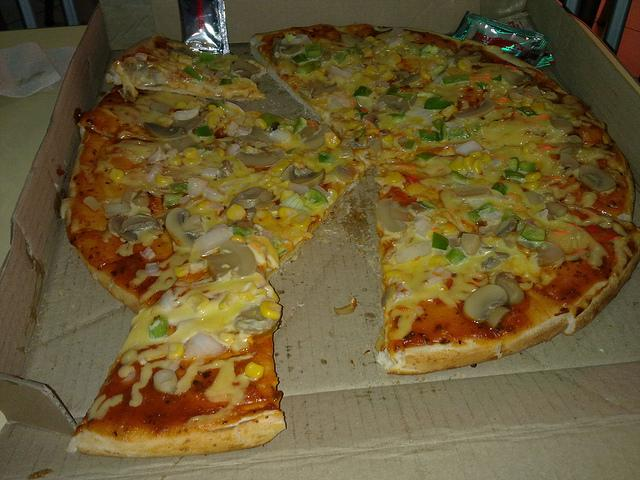What vegetable is the unusual one on the pizza?

Choices:
A) onions
B) green pepper
C) mushrooms
D) corn corn 